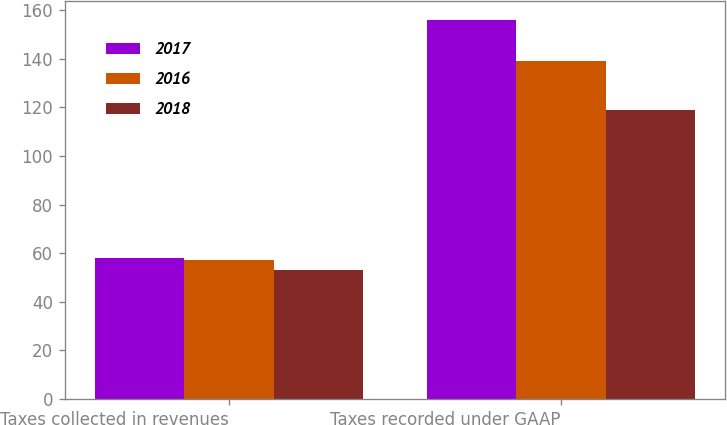Convert chart. <chart><loc_0><loc_0><loc_500><loc_500><stacked_bar_chart><ecel><fcel>Taxes collected in revenues<fcel>Taxes recorded under GAAP<nl><fcel>2017<fcel>58<fcel>156<nl><fcel>2016<fcel>57<fcel>139<nl><fcel>2018<fcel>53<fcel>119<nl></chart> 